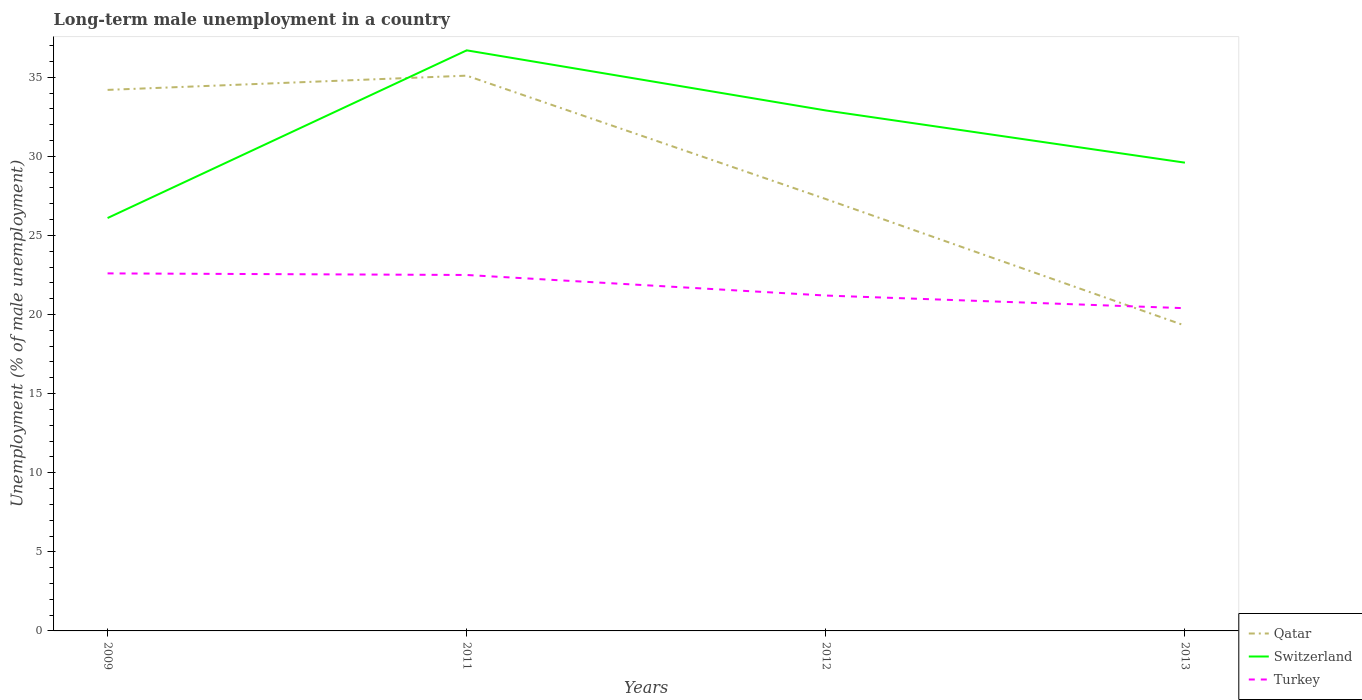Is the number of lines equal to the number of legend labels?
Offer a terse response. Yes. Across all years, what is the maximum percentage of long-term unemployed male population in Turkey?
Your answer should be very brief. 20.4. What is the total percentage of long-term unemployed male population in Switzerland in the graph?
Provide a succinct answer. -10.6. What is the difference between the highest and the second highest percentage of long-term unemployed male population in Turkey?
Ensure brevity in your answer.  2.2. Is the percentage of long-term unemployed male population in Qatar strictly greater than the percentage of long-term unemployed male population in Turkey over the years?
Provide a succinct answer. No. How many lines are there?
Your answer should be very brief. 3. How many years are there in the graph?
Ensure brevity in your answer.  4. Are the values on the major ticks of Y-axis written in scientific E-notation?
Ensure brevity in your answer.  No. Where does the legend appear in the graph?
Provide a short and direct response. Bottom right. How are the legend labels stacked?
Offer a very short reply. Vertical. What is the title of the graph?
Your answer should be compact. Long-term male unemployment in a country. What is the label or title of the Y-axis?
Provide a succinct answer. Unemployment (% of male unemployment). What is the Unemployment (% of male unemployment) of Qatar in 2009?
Offer a very short reply. 34.2. What is the Unemployment (% of male unemployment) of Switzerland in 2009?
Keep it short and to the point. 26.1. What is the Unemployment (% of male unemployment) of Turkey in 2009?
Give a very brief answer. 22.6. What is the Unemployment (% of male unemployment) of Qatar in 2011?
Provide a short and direct response. 35.1. What is the Unemployment (% of male unemployment) of Switzerland in 2011?
Make the answer very short. 36.7. What is the Unemployment (% of male unemployment) of Turkey in 2011?
Provide a succinct answer. 22.5. What is the Unemployment (% of male unemployment) of Qatar in 2012?
Provide a short and direct response. 27.3. What is the Unemployment (% of male unemployment) of Switzerland in 2012?
Give a very brief answer. 32.9. What is the Unemployment (% of male unemployment) in Turkey in 2012?
Ensure brevity in your answer.  21.2. What is the Unemployment (% of male unemployment) in Qatar in 2013?
Your answer should be very brief. 19.3. What is the Unemployment (% of male unemployment) of Switzerland in 2013?
Your response must be concise. 29.6. What is the Unemployment (% of male unemployment) of Turkey in 2013?
Keep it short and to the point. 20.4. Across all years, what is the maximum Unemployment (% of male unemployment) in Qatar?
Your answer should be very brief. 35.1. Across all years, what is the maximum Unemployment (% of male unemployment) in Switzerland?
Provide a succinct answer. 36.7. Across all years, what is the maximum Unemployment (% of male unemployment) in Turkey?
Your answer should be compact. 22.6. Across all years, what is the minimum Unemployment (% of male unemployment) of Qatar?
Provide a succinct answer. 19.3. Across all years, what is the minimum Unemployment (% of male unemployment) in Switzerland?
Offer a terse response. 26.1. Across all years, what is the minimum Unemployment (% of male unemployment) in Turkey?
Make the answer very short. 20.4. What is the total Unemployment (% of male unemployment) of Qatar in the graph?
Keep it short and to the point. 115.9. What is the total Unemployment (% of male unemployment) of Switzerland in the graph?
Ensure brevity in your answer.  125.3. What is the total Unemployment (% of male unemployment) of Turkey in the graph?
Give a very brief answer. 86.7. What is the difference between the Unemployment (% of male unemployment) in Turkey in 2009 and that in 2011?
Offer a terse response. 0.1. What is the difference between the Unemployment (% of male unemployment) in Switzerland in 2009 and that in 2012?
Ensure brevity in your answer.  -6.8. What is the difference between the Unemployment (% of male unemployment) of Qatar in 2009 and that in 2013?
Offer a very short reply. 14.9. What is the difference between the Unemployment (% of male unemployment) in Qatar in 2011 and that in 2012?
Provide a succinct answer. 7.8. What is the difference between the Unemployment (% of male unemployment) in Switzerland in 2011 and that in 2012?
Provide a short and direct response. 3.8. What is the difference between the Unemployment (% of male unemployment) in Turkey in 2011 and that in 2012?
Your response must be concise. 1.3. What is the difference between the Unemployment (% of male unemployment) in Qatar in 2011 and that in 2013?
Provide a short and direct response. 15.8. What is the difference between the Unemployment (% of male unemployment) in Turkey in 2011 and that in 2013?
Your answer should be compact. 2.1. What is the difference between the Unemployment (% of male unemployment) of Qatar in 2009 and the Unemployment (% of male unemployment) of Switzerland in 2011?
Provide a succinct answer. -2.5. What is the difference between the Unemployment (% of male unemployment) of Switzerland in 2009 and the Unemployment (% of male unemployment) of Turkey in 2011?
Keep it short and to the point. 3.6. What is the difference between the Unemployment (% of male unemployment) of Qatar in 2009 and the Unemployment (% of male unemployment) of Switzerland in 2012?
Give a very brief answer. 1.3. What is the difference between the Unemployment (% of male unemployment) of Qatar in 2009 and the Unemployment (% of male unemployment) of Turkey in 2012?
Provide a succinct answer. 13. What is the difference between the Unemployment (% of male unemployment) in Switzerland in 2009 and the Unemployment (% of male unemployment) in Turkey in 2013?
Give a very brief answer. 5.7. What is the difference between the Unemployment (% of male unemployment) in Qatar in 2011 and the Unemployment (% of male unemployment) in Switzerland in 2012?
Your response must be concise. 2.2. What is the difference between the Unemployment (% of male unemployment) of Qatar in 2011 and the Unemployment (% of male unemployment) of Switzerland in 2013?
Your answer should be very brief. 5.5. What is the difference between the Unemployment (% of male unemployment) of Qatar in 2011 and the Unemployment (% of male unemployment) of Turkey in 2013?
Offer a very short reply. 14.7. What is the difference between the Unemployment (% of male unemployment) in Switzerland in 2011 and the Unemployment (% of male unemployment) in Turkey in 2013?
Offer a very short reply. 16.3. What is the difference between the Unemployment (% of male unemployment) in Qatar in 2012 and the Unemployment (% of male unemployment) in Turkey in 2013?
Keep it short and to the point. 6.9. What is the difference between the Unemployment (% of male unemployment) of Switzerland in 2012 and the Unemployment (% of male unemployment) of Turkey in 2013?
Provide a short and direct response. 12.5. What is the average Unemployment (% of male unemployment) of Qatar per year?
Offer a very short reply. 28.98. What is the average Unemployment (% of male unemployment) of Switzerland per year?
Give a very brief answer. 31.32. What is the average Unemployment (% of male unemployment) of Turkey per year?
Offer a terse response. 21.68. In the year 2009, what is the difference between the Unemployment (% of male unemployment) of Qatar and Unemployment (% of male unemployment) of Switzerland?
Give a very brief answer. 8.1. In the year 2009, what is the difference between the Unemployment (% of male unemployment) in Switzerland and Unemployment (% of male unemployment) in Turkey?
Offer a very short reply. 3.5. In the year 2011, what is the difference between the Unemployment (% of male unemployment) in Qatar and Unemployment (% of male unemployment) in Turkey?
Provide a short and direct response. 12.6. In the year 2011, what is the difference between the Unemployment (% of male unemployment) of Switzerland and Unemployment (% of male unemployment) of Turkey?
Your answer should be very brief. 14.2. In the year 2012, what is the difference between the Unemployment (% of male unemployment) in Qatar and Unemployment (% of male unemployment) in Turkey?
Offer a very short reply. 6.1. In the year 2013, what is the difference between the Unemployment (% of male unemployment) of Qatar and Unemployment (% of male unemployment) of Switzerland?
Make the answer very short. -10.3. In the year 2013, what is the difference between the Unemployment (% of male unemployment) of Qatar and Unemployment (% of male unemployment) of Turkey?
Ensure brevity in your answer.  -1.1. What is the ratio of the Unemployment (% of male unemployment) of Qatar in 2009 to that in 2011?
Your answer should be compact. 0.97. What is the ratio of the Unemployment (% of male unemployment) of Switzerland in 2009 to that in 2011?
Offer a very short reply. 0.71. What is the ratio of the Unemployment (% of male unemployment) of Qatar in 2009 to that in 2012?
Offer a very short reply. 1.25. What is the ratio of the Unemployment (% of male unemployment) in Switzerland in 2009 to that in 2012?
Provide a short and direct response. 0.79. What is the ratio of the Unemployment (% of male unemployment) of Turkey in 2009 to that in 2012?
Provide a succinct answer. 1.07. What is the ratio of the Unemployment (% of male unemployment) in Qatar in 2009 to that in 2013?
Offer a terse response. 1.77. What is the ratio of the Unemployment (% of male unemployment) in Switzerland in 2009 to that in 2013?
Provide a short and direct response. 0.88. What is the ratio of the Unemployment (% of male unemployment) of Turkey in 2009 to that in 2013?
Your answer should be compact. 1.11. What is the ratio of the Unemployment (% of male unemployment) of Switzerland in 2011 to that in 2012?
Keep it short and to the point. 1.12. What is the ratio of the Unemployment (% of male unemployment) in Turkey in 2011 to that in 2012?
Make the answer very short. 1.06. What is the ratio of the Unemployment (% of male unemployment) in Qatar in 2011 to that in 2013?
Your answer should be compact. 1.82. What is the ratio of the Unemployment (% of male unemployment) of Switzerland in 2011 to that in 2013?
Offer a very short reply. 1.24. What is the ratio of the Unemployment (% of male unemployment) in Turkey in 2011 to that in 2013?
Offer a very short reply. 1.1. What is the ratio of the Unemployment (% of male unemployment) in Qatar in 2012 to that in 2013?
Your answer should be compact. 1.41. What is the ratio of the Unemployment (% of male unemployment) in Switzerland in 2012 to that in 2013?
Your answer should be compact. 1.11. What is the ratio of the Unemployment (% of male unemployment) of Turkey in 2012 to that in 2013?
Keep it short and to the point. 1.04. What is the difference between the highest and the second highest Unemployment (% of male unemployment) in Switzerland?
Keep it short and to the point. 3.8. What is the difference between the highest and the second highest Unemployment (% of male unemployment) in Turkey?
Offer a terse response. 0.1. 